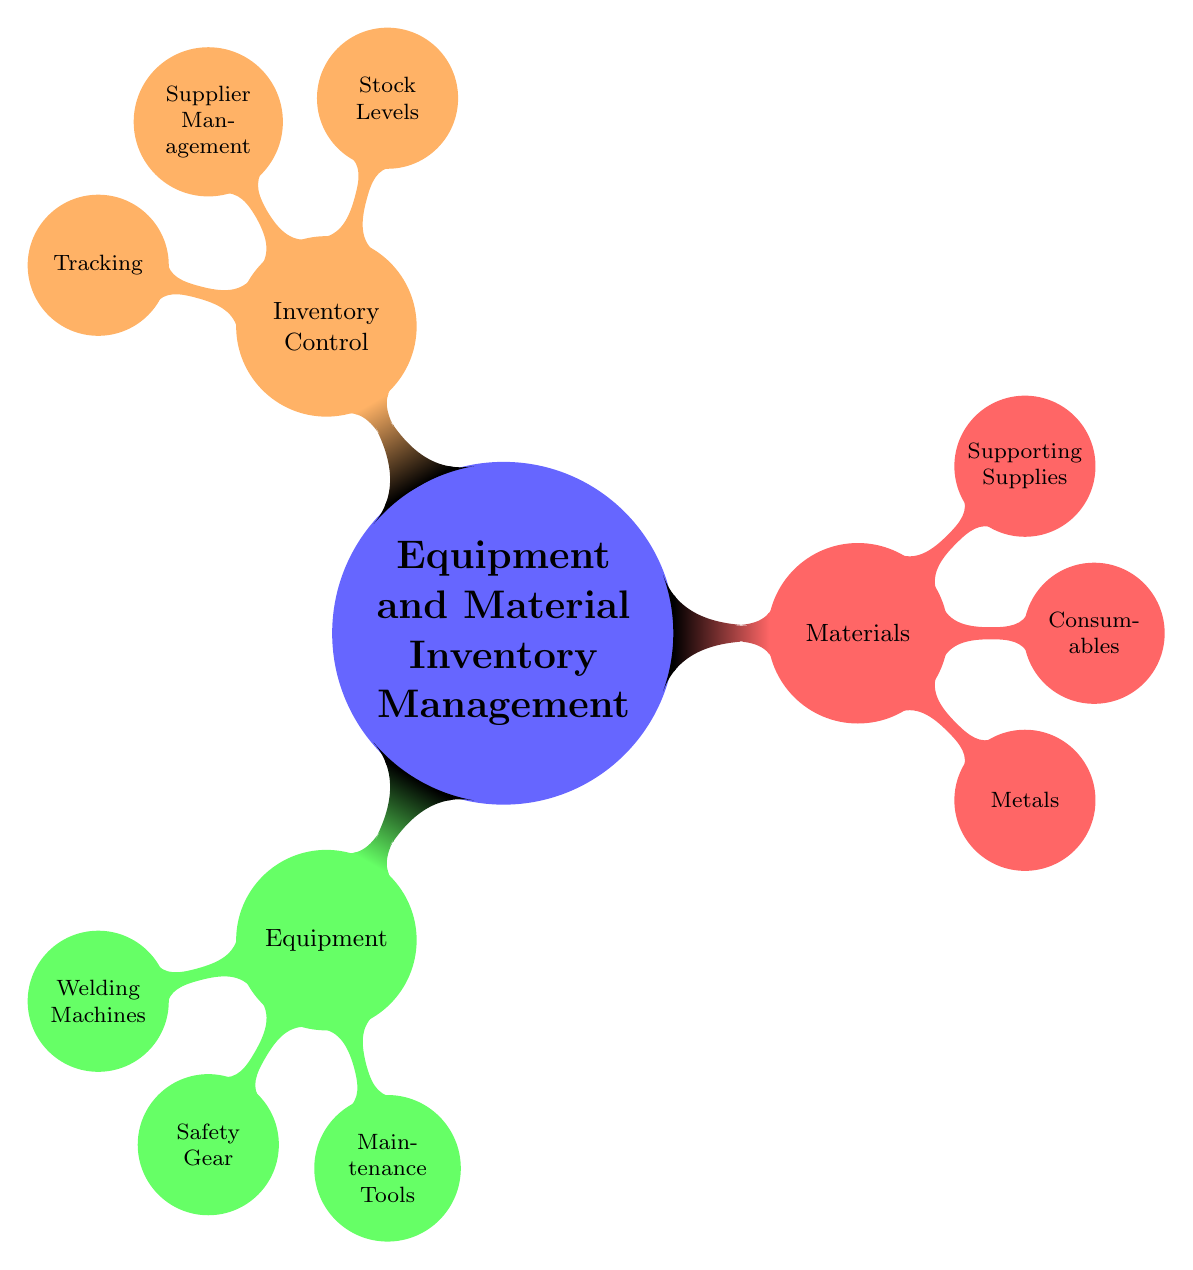What are the three categories of equipment listed? The diagram displays three nodes under the "Equipment" category: "Welding Machines," "Safety Gear," and "Maintenance Tools."
Answer: Welding Machines, Safety Gear, Maintenance Tools How many types of metals are mentioned? Under the "Materials" category, three specific types of metals are listed: "Steel Plates," "Aluminum Sheets," and "Copper Tubes."
Answer: 3 What is the node that corresponds to tracking? The diagram shows "Tracking" as a sub-node under "Inventory Control."
Answer: Tracking Which category includes "Welding Rods"? The "Consumables" node under "Materials" includes "Welding Rods."
Answer: Materials What are the three inventory control aspects listed? The "Inventory Control" section includes three aspects: "Stock Levels," "Supplier Management," and "Tracking."
Answer: Stock Levels, Supplier Management, Tracking How many types of welding machines are characterized in the diagram? The "Welding Machines" node details three types: "MIG Welders," "TIG Welders," and "Stick Welders."
Answer: 3 Which sub-category is under "Materials" that involves supplies? The sub-category under "Materials" that involves supplies is "Supporting Supplies."
Answer: Supporting Supplies What is the focus of the "Supplier Management" node? The "Supplier Management" node includes aspects related to managing suppliers for inventory, such as "Approved Vendors," "Lead Times," and "Cost Management."
Answer: Supplier Management How are inventory items tracked according to the diagram? The diagram suggests that inventory items can be tracked using "Barcoding," "RFID Tags," and "Inventory Software" under the "Tracking" node.
Answer: Barcoding, RFID Tags, Inventory Software 